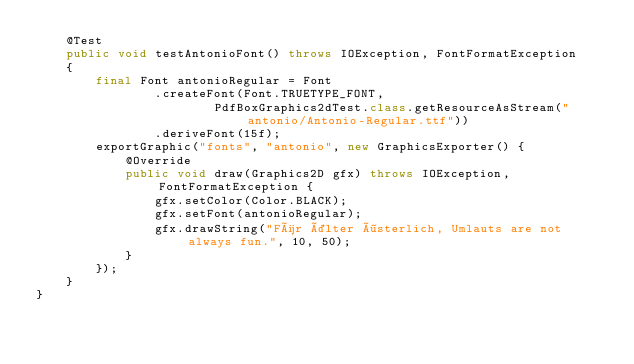<code> <loc_0><loc_0><loc_500><loc_500><_Java_>	@Test
	public void testAntonioFont() throws IOException, FontFormatException
	{
		final Font antonioRegular = Font
				.createFont(Font.TRUETYPE_FONT,
						PdfBoxGraphics2dTest.class.getResourceAsStream("antonio/Antonio-Regular.ttf"))
				.deriveFont(15f);
		exportGraphic("fonts", "antonio", new GraphicsExporter() {
			@Override
			public void draw(Graphics2D gfx) throws IOException, FontFormatException {
				gfx.setColor(Color.BLACK);
				gfx.setFont(antonioRegular);
				gfx.drawString("Für älter österlich, Umlauts are not always fun.", 10, 50);
			}
		});
	}
}
</code> 